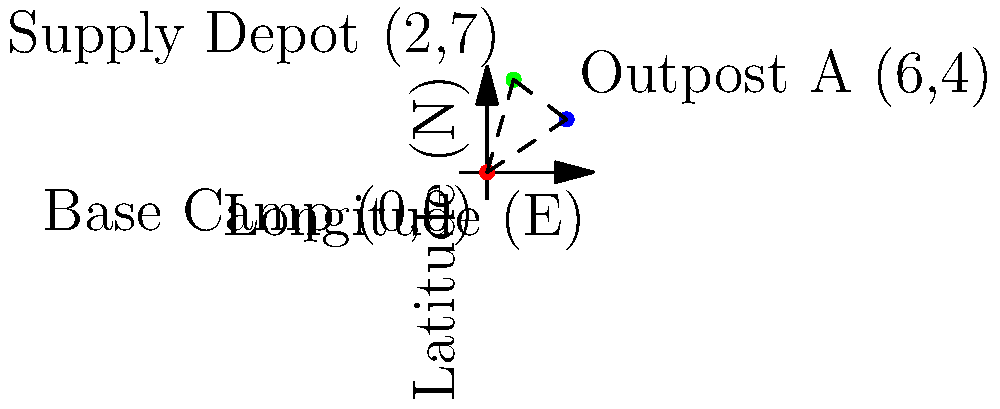A military operation requires planning a supply route from the Base Camp to Outpost A, then to a Supply Depot. Given the GPS coordinates of these locations (Base Camp: 0°N, 0°E; Outpost A: 4°N, 6°E; Supply Depot: 7°N, 2°E), calculate the total distance of the route in kilometers. Assume 1° of latitude or longitude equals 111 km, and use the Euclidean distance formula. To solve this problem, we'll use the Euclidean distance formula and calculate the distances between each pair of points:

1. Distance from Base Camp to Outpost A:
   $d_1 = \sqrt{(x_2-x_1)^2 + (y_2-y_1)^2} \times 111$
   $d_1 = \sqrt{(6-0)^2 + (4-0)^2} \times 111$
   $d_1 = \sqrt{36 + 16} \times 111 = \sqrt{52} \times 111 \approx 800.44$ km

2. Distance from Outpost A to Supply Depot:
   $d_2 = \sqrt{(x_3-x_2)^2 + (y_3-y_2)^2} \times 111$
   $d_2 = \sqrt{(2-6)^2 + (7-4)^2} \times 111$
   $d_2 = \sqrt{16 + 9} \times 111 = \sqrt{25} \times 111 = 5 \times 111 = 555$ km

3. Total distance:
   $d_{total} = d_1 + d_2 = 800.44 + 555 = 1355.44$ km

Therefore, the total distance of the supply route is approximately 1355.44 km.
Answer: 1355.44 km 